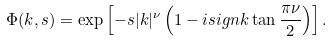Convert formula to latex. <formula><loc_0><loc_0><loc_500><loc_500>\Phi ( k , s ) = \exp \left [ - s | k | ^ { \nu } \left ( 1 - i s i g n k \tan \frac { \pi \nu } { 2 } \right ) \right ] .</formula> 